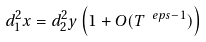Convert formula to latex. <formula><loc_0><loc_0><loc_500><loc_500>d _ { 1 } ^ { 2 } x = d _ { 2 } ^ { 2 } y \left ( 1 + O ( T ^ { \ e p s - 1 } ) \right )</formula> 